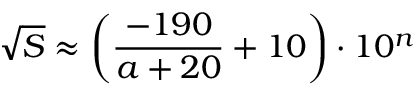Convert formula to latex. <formula><loc_0><loc_0><loc_500><loc_500>{ \sqrt { S } } \approx \left ( { \frac { - 1 9 0 } { a + 2 0 } } + 1 0 \right ) \cdot 1 0 ^ { n }</formula> 